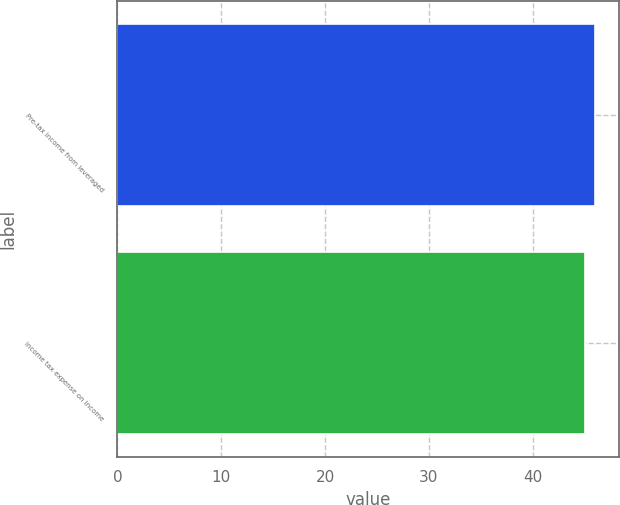Convert chart to OTSL. <chart><loc_0><loc_0><loc_500><loc_500><bar_chart><fcel>Pre-tax income from leveraged<fcel>Income tax expense on income<nl><fcel>46<fcel>45<nl></chart> 